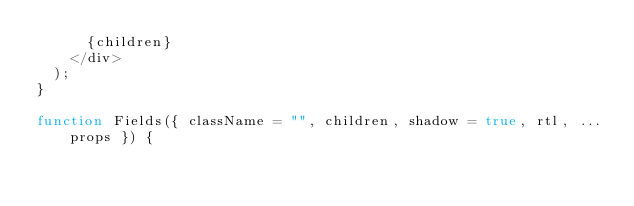<code> <loc_0><loc_0><loc_500><loc_500><_JavaScript_>      {children}
    </div>
  );
}

function Fields({ className = "", children, shadow = true, rtl, ...props }) {</code> 